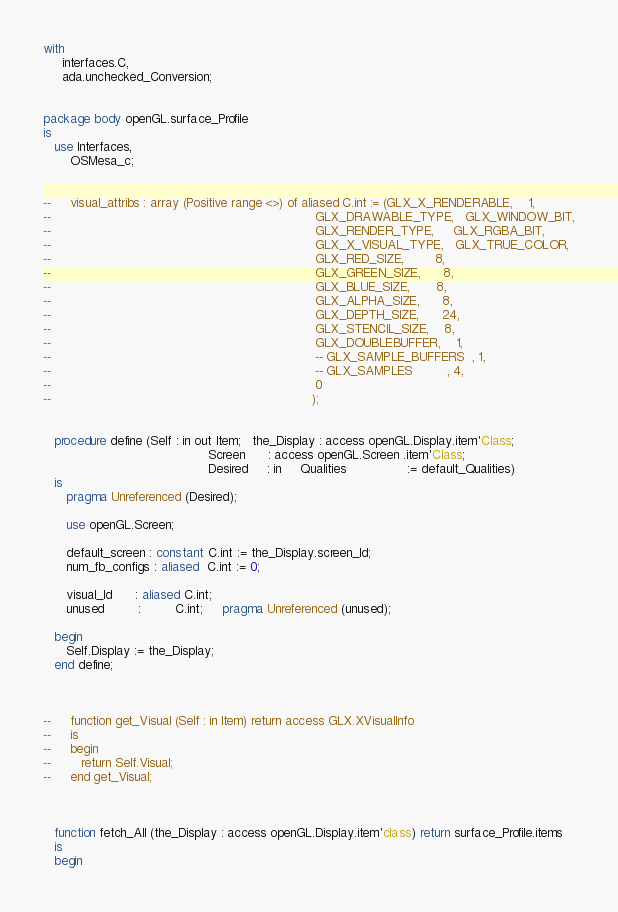<code> <loc_0><loc_0><loc_500><loc_500><_Ada_>with
     interfaces.C,
     ada.unchecked_Conversion;


package body openGL.surface_Profile
is
   use Interfaces,
       OSMesa_c;


--     visual_attribs : array (Positive range <>) of aliased C.int := (GLX_X_RENDERABLE,    1,
--                                                                     GLX_DRAWABLE_TYPE,   GLX_WINDOW_BIT,
--                                                                     GLX_RENDER_TYPE,     GLX_RGBA_BIT,
--                                                                     GLX_X_VISUAL_TYPE,   GLX_TRUE_COLOR,
--                                                                     GLX_RED_SIZE,        8,
--                                                                     GLX_GREEN_SIZE,      8,
--                                                                     GLX_BLUE_SIZE,       8,
--                                                                     GLX_ALPHA_SIZE,      8,
--                                                                     GLX_DEPTH_SIZE,      24,
--                                                                     GLX_STENCIL_SIZE,    8,
--                                                                     GLX_DOUBLEBUFFER,    1,
--                                                                     -- GLX_SAMPLE_BUFFERS  , 1,
--                                                                     -- GLX_SAMPLES         , 4,
--                                                                     0
--                                                                    );


   procedure define (Self : in out Item;   the_Display : access openGL.Display.item'Class;
                                           Screen      : access openGL.Screen .item'Class;
                                           Desired     : in     Qualities                := default_Qualities)
   is
      pragma Unreferenced (Desired);

      use openGL.Screen;

      default_screen : constant C.int := the_Display.screen_Id;
      num_fb_configs : aliased  C.int := 0;

      visual_Id      : aliased C.int;
      unused         :         C.int;     pragma Unreferenced (unused);

   begin
      Self.Display := the_Display;
   end define;



--     function get_Visual (Self : in Item) return access GLX.XVisualInfo
--     is
--     begin
--        return Self.Visual;
--     end get_Visual;



   function fetch_All (the_Display : access openGL.Display.item'class) return surface_Profile.items
   is
   begin</code> 